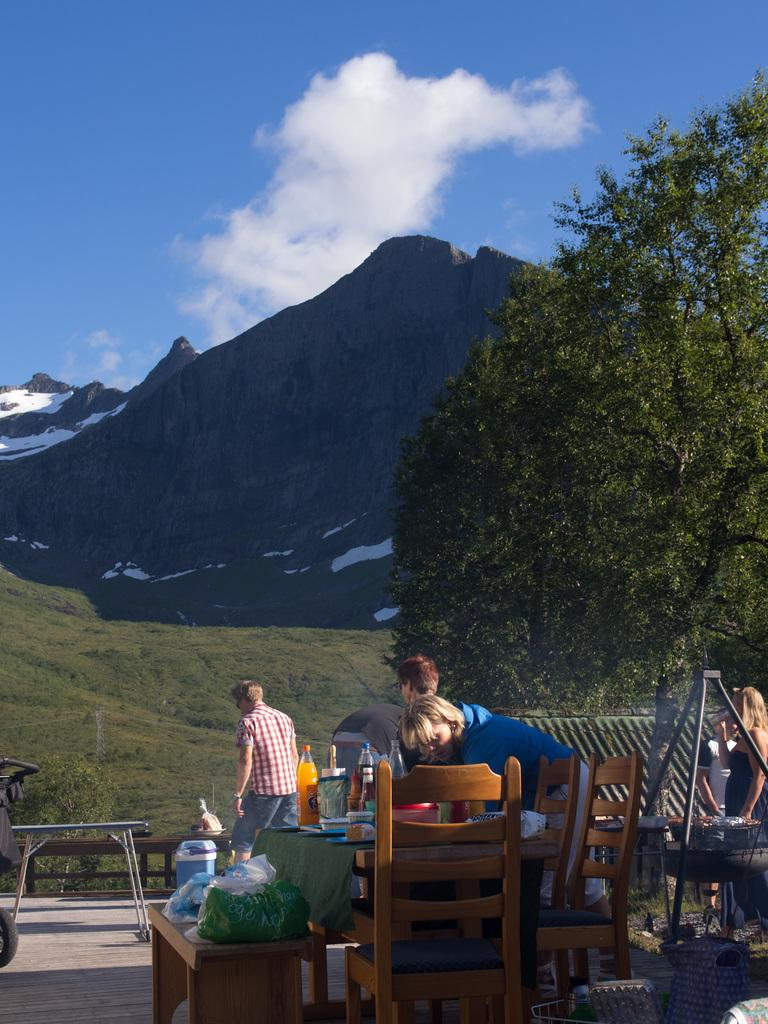How many people are in the image? There are three persons in the image. What furniture is present in the image? There is a table and chairs in the image. What objects can be seen on the table? There are bottles on the table. What can be seen in the background of the image? Trees, a mountain, and the sky are visible in the background of the image. What is the condition of the sky in the image? Clouds are present in the sky. Can you tell me how many boats are floating on the lake in the image? There is no lake or boat present in the image. What type of sink is visible in the image? There is no sink present in the image. 